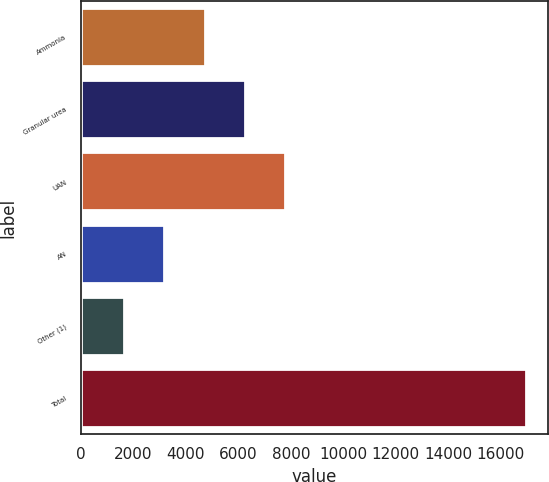Convert chart. <chart><loc_0><loc_0><loc_500><loc_500><bar_chart><fcel>Ammonia<fcel>Granular urea<fcel>UAN<fcel>AN<fcel>Other (1)<fcel>Total<nl><fcel>4714.6<fcel>6244.9<fcel>7775.2<fcel>3184.3<fcel>1654<fcel>16957<nl></chart> 